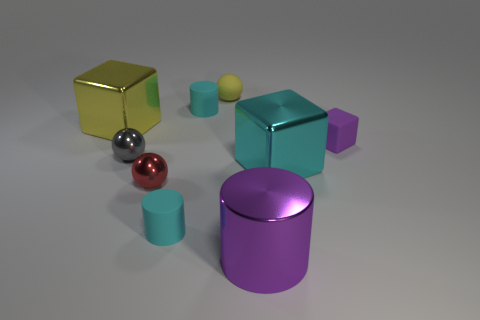What material is the large cylinder that is the same color as the small cube?
Your answer should be compact. Metal. What is the shape of the yellow matte object that is the same size as the gray metal ball?
Your answer should be compact. Sphere. How many other things are the same color as the rubber cube?
Your answer should be compact. 1. What number of blue things are either matte cylinders or tiny rubber blocks?
Your answer should be compact. 0. Is the shape of the big object that is left of the purple metal cylinder the same as the small cyan object in front of the large yellow block?
Your answer should be compact. No. What number of other things are there of the same material as the big yellow block
Your answer should be very brief. 4. There is a large shiny block that is left of the small cyan matte thing that is in front of the yellow metallic block; are there any large yellow things to the left of it?
Your response must be concise. No. Is the big yellow cube made of the same material as the large purple object?
Ensure brevity in your answer.  Yes. What is the yellow object behind the cyan rubber object that is behind the big cyan shiny thing made of?
Offer a very short reply. Rubber. How big is the yellow thing left of the yellow matte sphere?
Offer a very short reply. Large. 